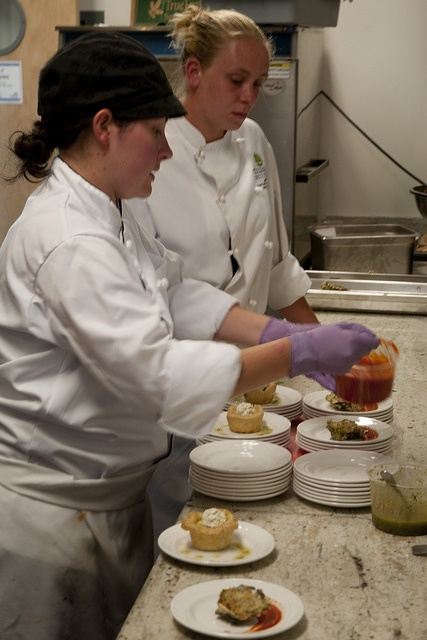Describe the objects in this image and their specific colors. I can see people in black, gray, darkgray, and lightgray tones, people in black, darkgray, maroon, and gray tones, bowl in black, olive, and gray tones, bowl in black, maroon, brown, tan, and gray tones, and cake in black, olive, and tan tones in this image. 